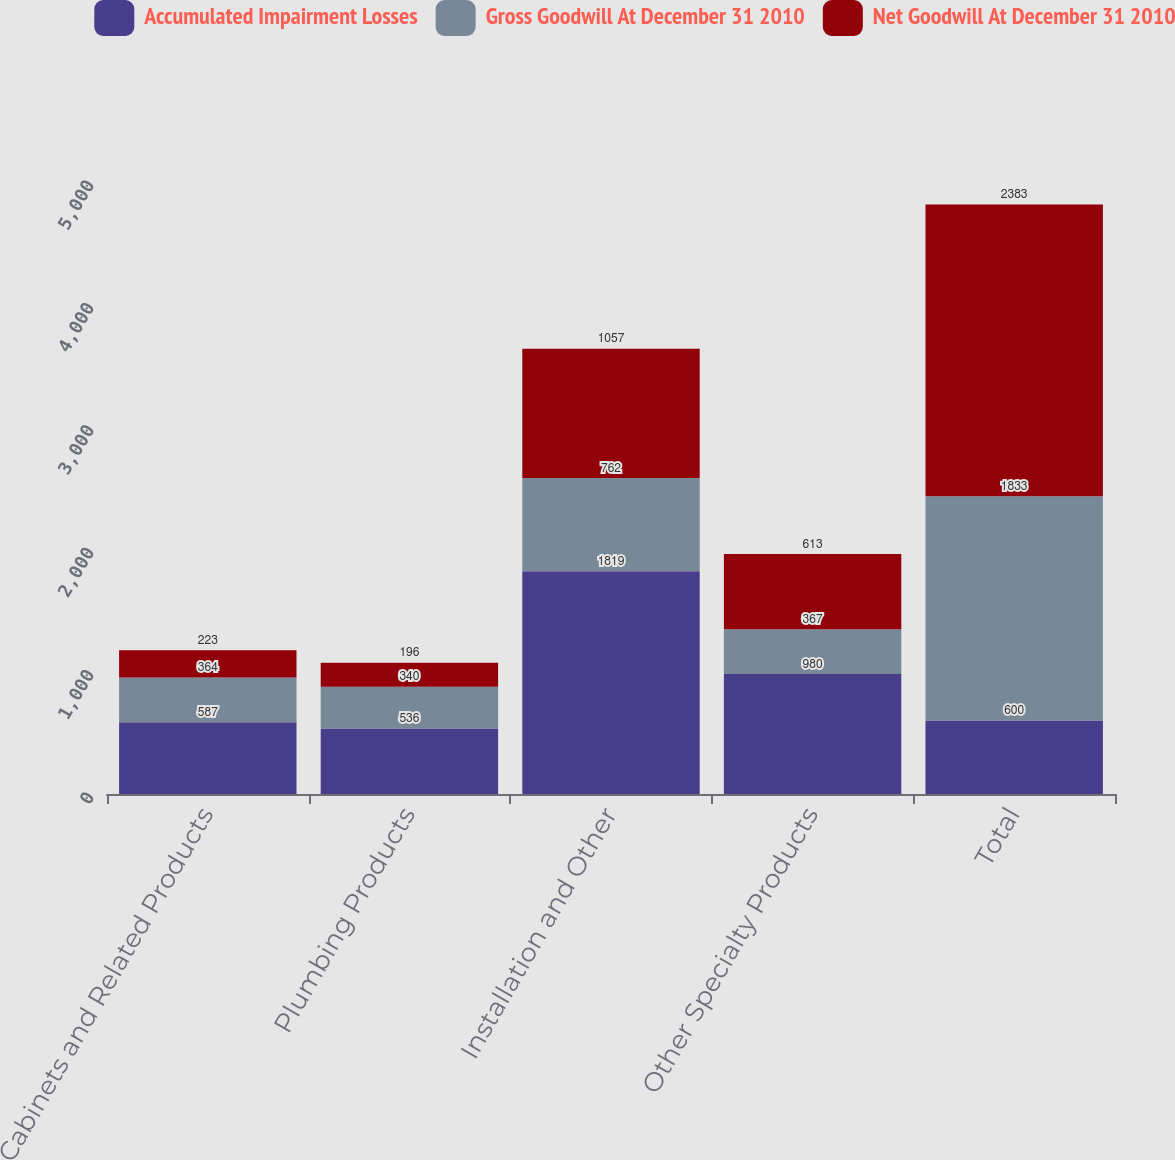Convert chart to OTSL. <chart><loc_0><loc_0><loc_500><loc_500><stacked_bar_chart><ecel><fcel>Cabinets and Related Products<fcel>Plumbing Products<fcel>Installation and Other<fcel>Other Specialty Products<fcel>Total<nl><fcel>Accumulated Impairment Losses<fcel>587<fcel>536<fcel>1819<fcel>980<fcel>600<nl><fcel>Gross Goodwill At December 31 2010<fcel>364<fcel>340<fcel>762<fcel>367<fcel>1833<nl><fcel>Net Goodwill At December 31 2010<fcel>223<fcel>196<fcel>1057<fcel>613<fcel>2383<nl></chart> 